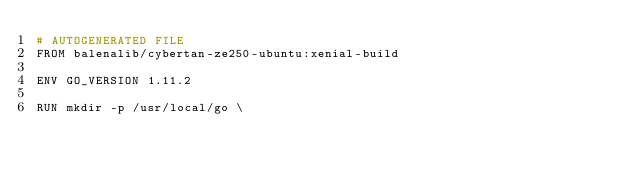Convert code to text. <code><loc_0><loc_0><loc_500><loc_500><_Dockerfile_># AUTOGENERATED FILE
FROM balenalib/cybertan-ze250-ubuntu:xenial-build

ENV GO_VERSION 1.11.2

RUN mkdir -p /usr/local/go \</code> 